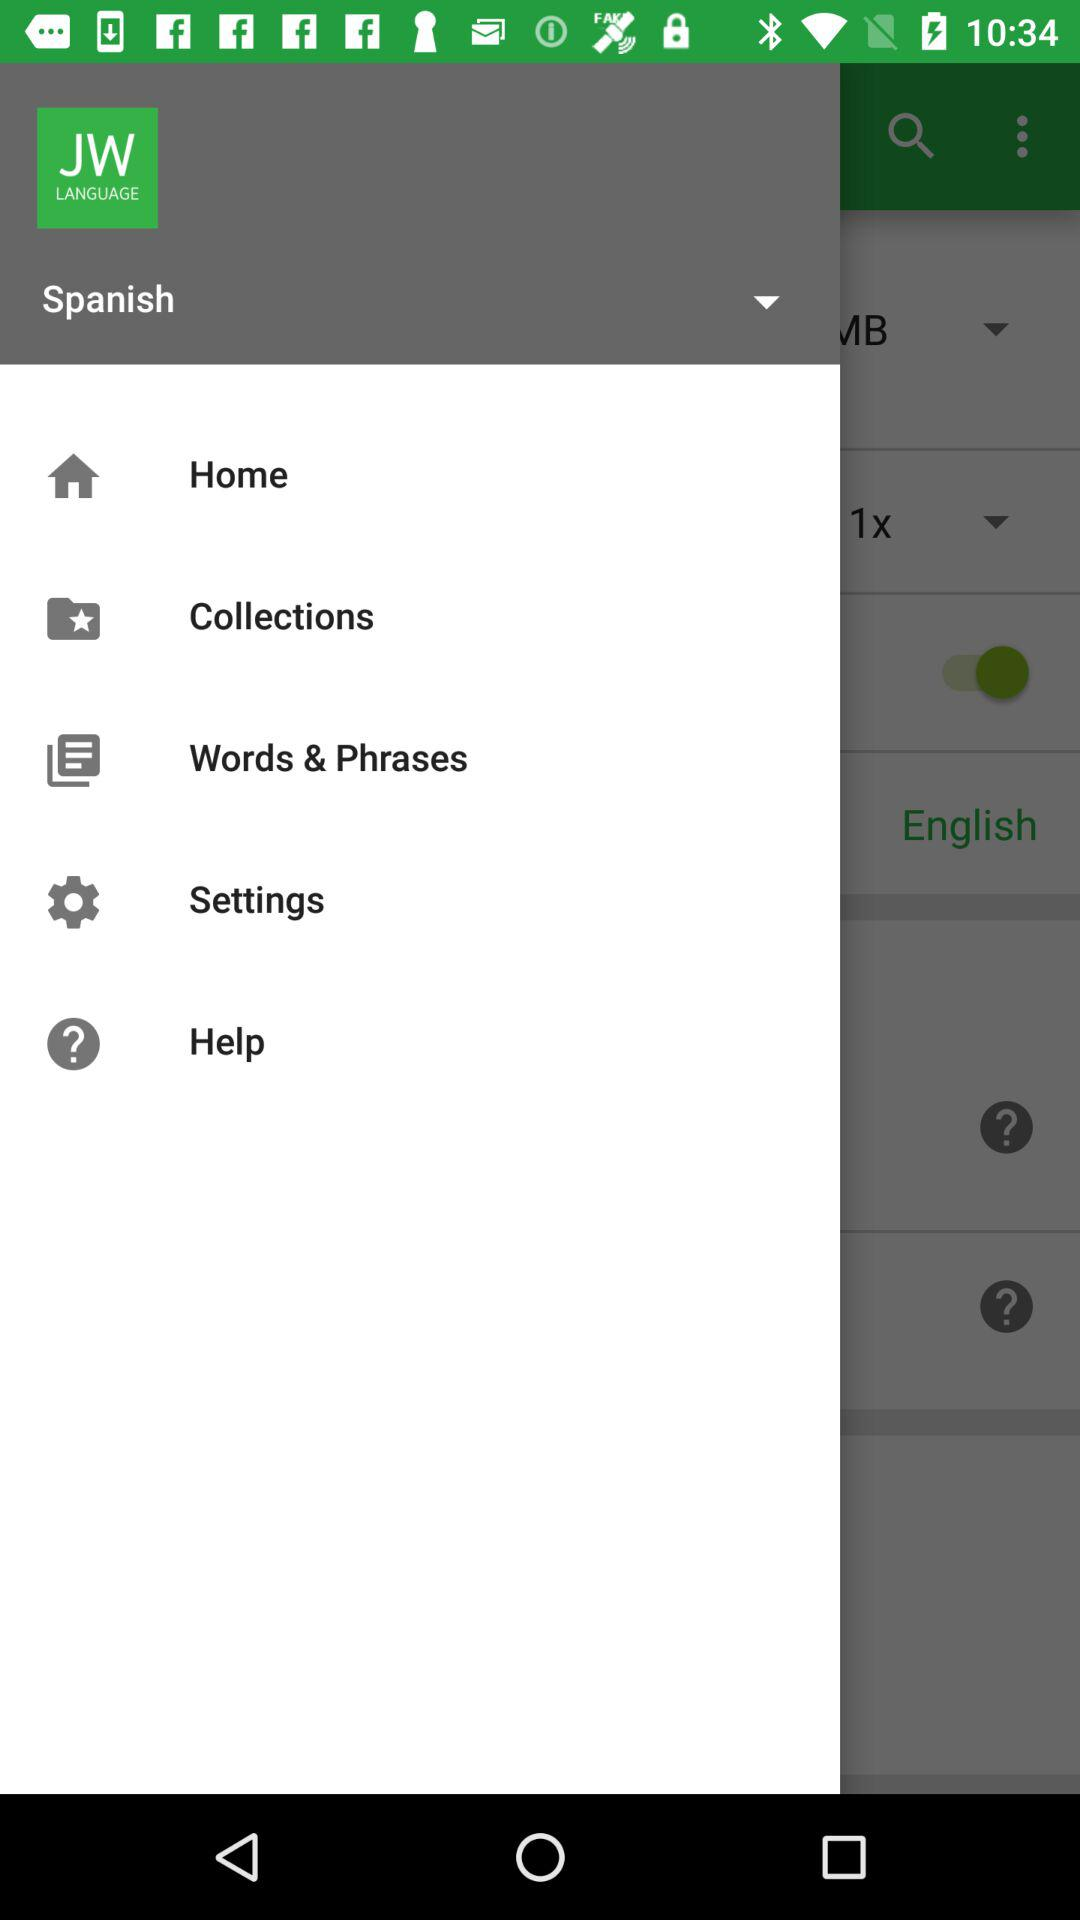Which language is selected? The selected language is Spanish. 